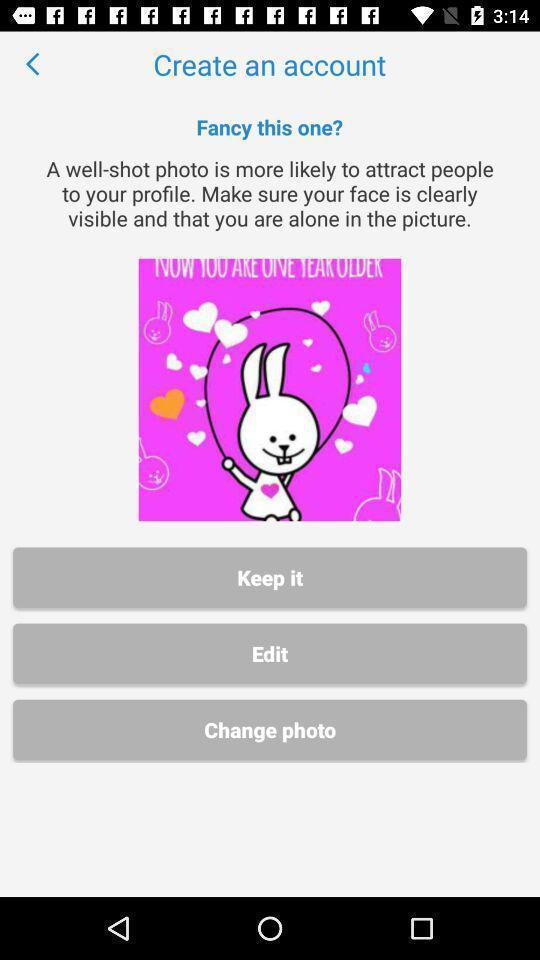What is the overall content of this screenshot? Page for uploading a photo for creating an account. 